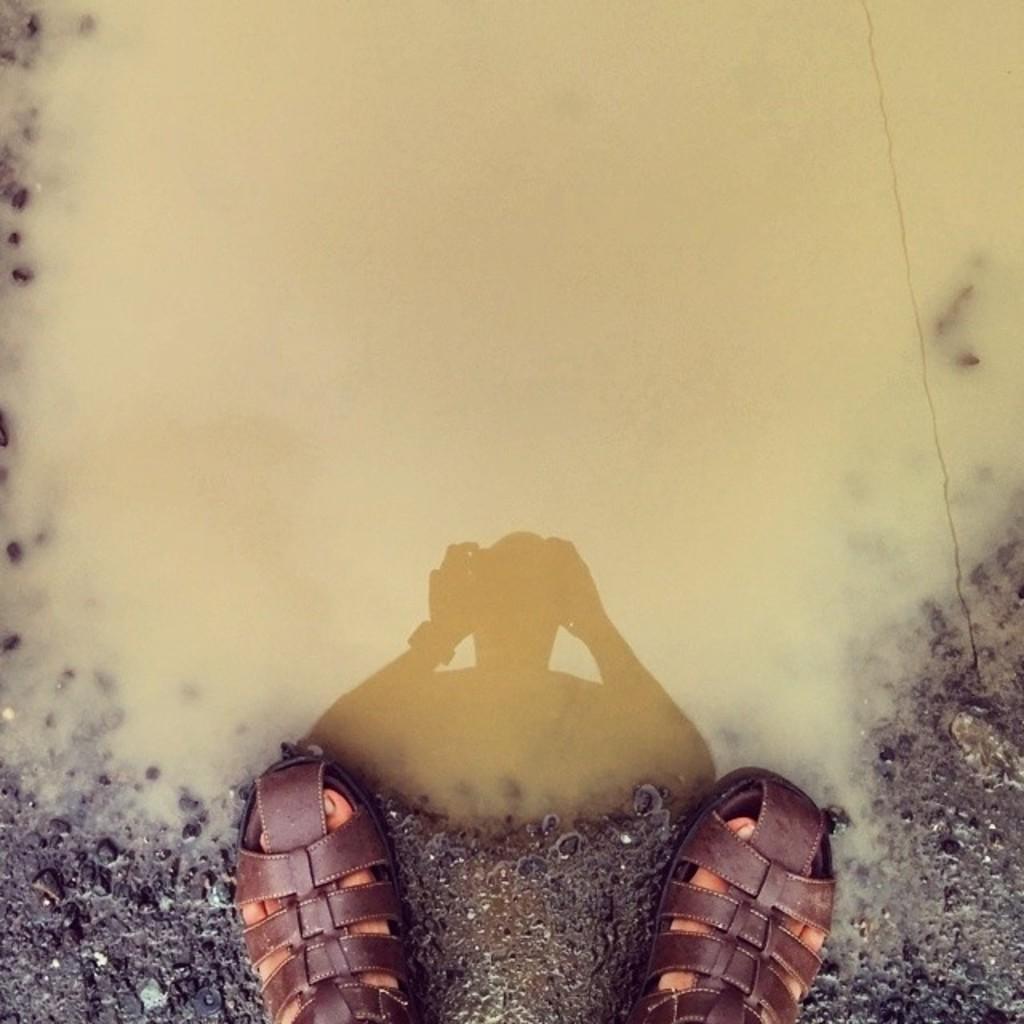Can you describe this image briefly? In this picture we can see a person's feet with footwear and in the background we can see mud water. 